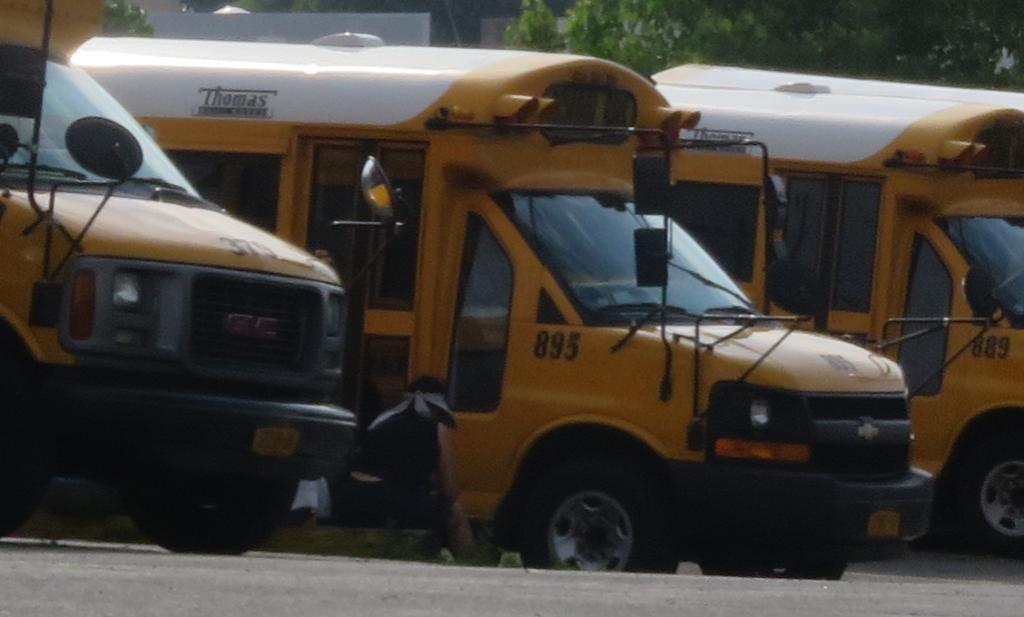What color are the vehicles in the image? The vehicles in the image are yellow. Where are the vehicles located in the image? The vehicles are on the left side of the image. What else can be seen in the image besides the vehicles? There are trees visible in the image. What type of sack is being used to carry the bulbs in the image? There is no sack or bulbs present in the image; it only features yellow vehicles and trees. 